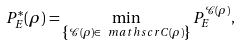<formula> <loc_0><loc_0><loc_500><loc_500>P ^ { * } _ { E } ( \rho ) = \min _ { \left \{ \mathcal { C } ( \rho ) \in \ m a t h s c r { C } ( \rho ) \right \} } P ^ { \mathcal { C } ( \rho ) } _ { E } ,</formula> 